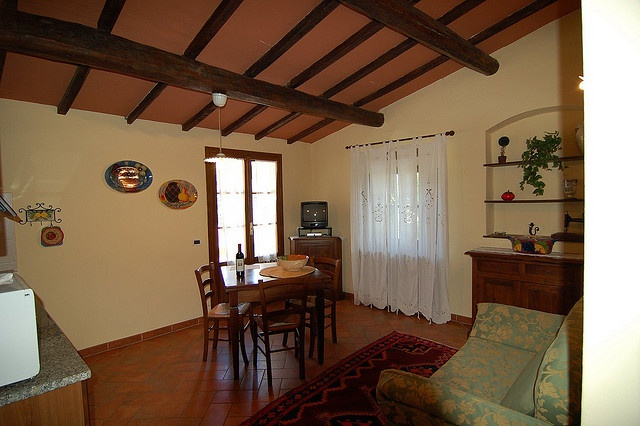Describe the objects in this image and their specific colors. I can see couch in black, olive, and maroon tones, chair in black, maroon, and gray tones, chair in black, maroon, and gray tones, dining table in black, lightgray, gray, and brown tones, and chair in black, maroon, and brown tones in this image. 